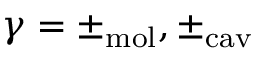<formula> <loc_0><loc_0><loc_500><loc_500>\gamma = \pm _ { m o l } , \pm _ { c a v }</formula> 